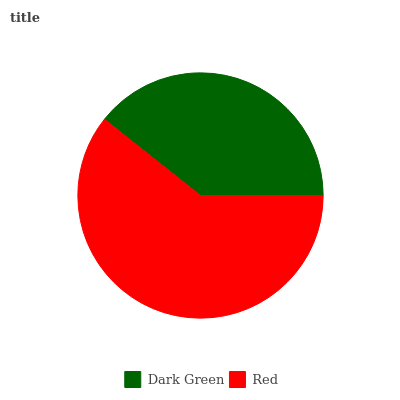Is Dark Green the minimum?
Answer yes or no. Yes. Is Red the maximum?
Answer yes or no. Yes. Is Red the minimum?
Answer yes or no. No. Is Red greater than Dark Green?
Answer yes or no. Yes. Is Dark Green less than Red?
Answer yes or no. Yes. Is Dark Green greater than Red?
Answer yes or no. No. Is Red less than Dark Green?
Answer yes or no. No. Is Red the high median?
Answer yes or no. Yes. Is Dark Green the low median?
Answer yes or no. Yes. Is Dark Green the high median?
Answer yes or no. No. Is Red the low median?
Answer yes or no. No. 